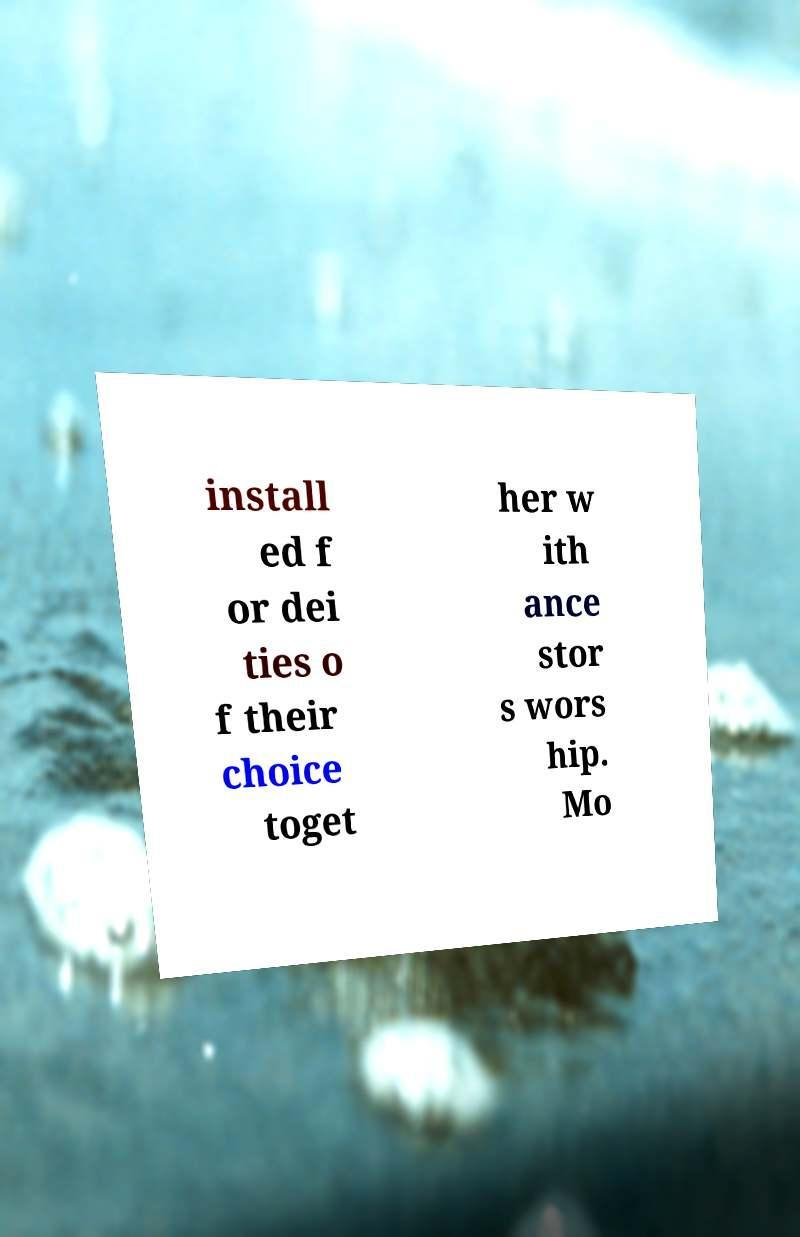There's text embedded in this image that I need extracted. Can you transcribe it verbatim? install ed f or dei ties o f their choice toget her w ith ance stor s wors hip. Mo 